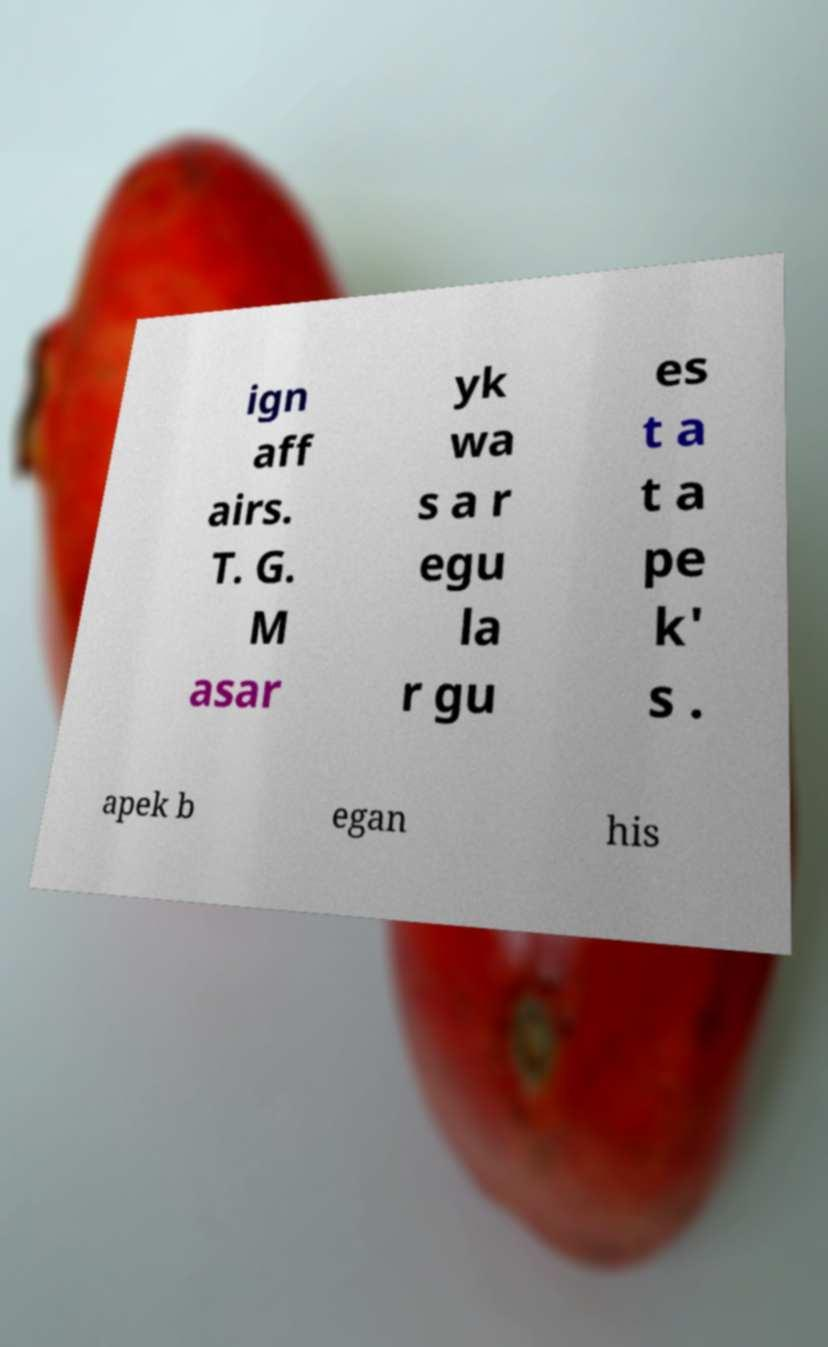There's text embedded in this image that I need extracted. Can you transcribe it verbatim? ign aff airs. T. G. M asar yk wa s a r egu la r gu es t a t a pe k' s . apek b egan his 